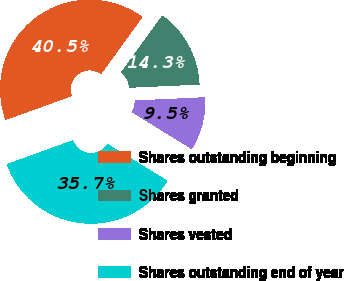Convert chart to OTSL. <chart><loc_0><loc_0><loc_500><loc_500><pie_chart><fcel>Shares outstanding beginning<fcel>Shares granted<fcel>Shares vested<fcel>Shares outstanding end of year<nl><fcel>40.48%<fcel>14.29%<fcel>9.52%<fcel>35.71%<nl></chart> 